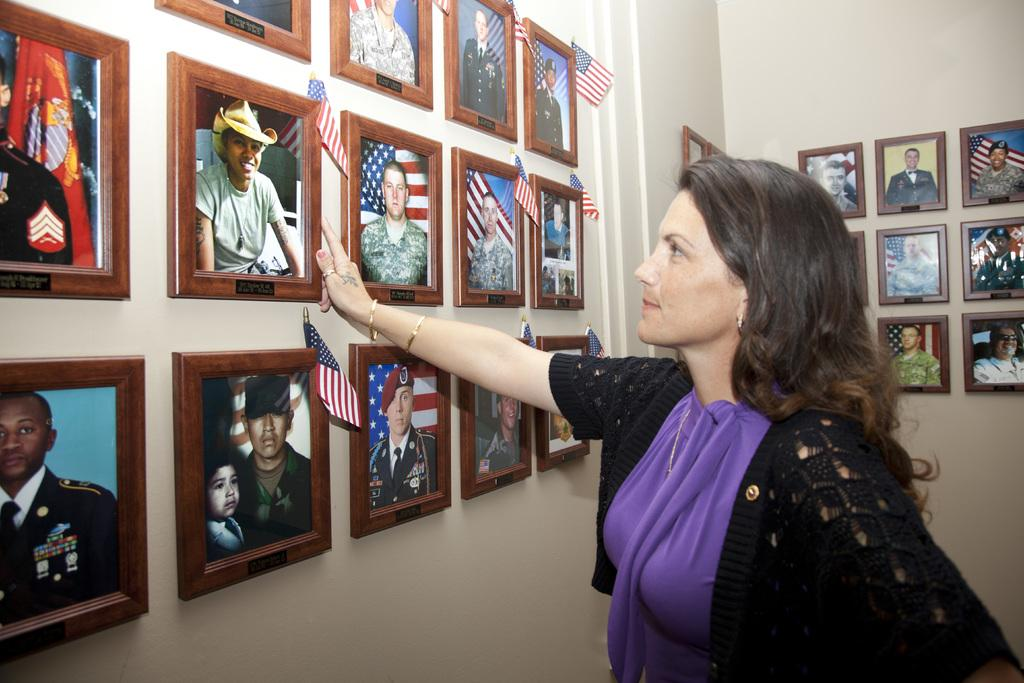Who is present in the image? There is a woman in the image. What decorations can be seen on the walls? There are flags and frames on the walls. What type of jeans is the woman wearing in the image? There is no information about the woman's clothing in the image, so it cannot be determined if she is wearing jeans or any other type of clothing. 